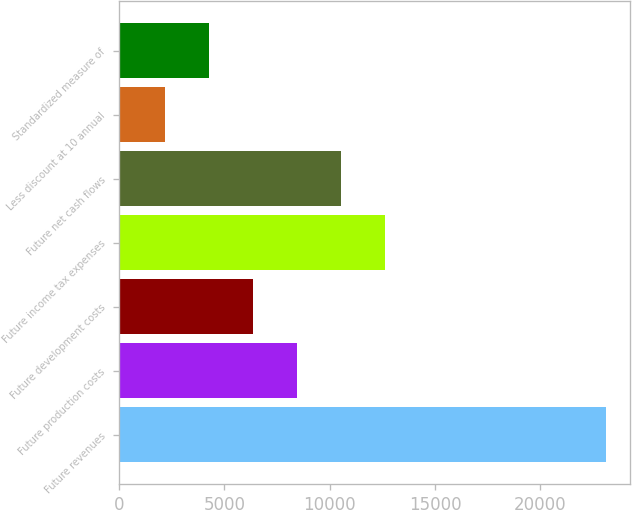Convert chart. <chart><loc_0><loc_0><loc_500><loc_500><bar_chart><fcel>Future revenues<fcel>Future production costs<fcel>Future development costs<fcel>Future income tax expenses<fcel>Future net cash flows<fcel>Less discount at 10 annual<fcel>Standardized measure of<nl><fcel>23115<fcel>8443.7<fcel>6347.8<fcel>12635.5<fcel>10539.6<fcel>2156<fcel>4251.9<nl></chart> 